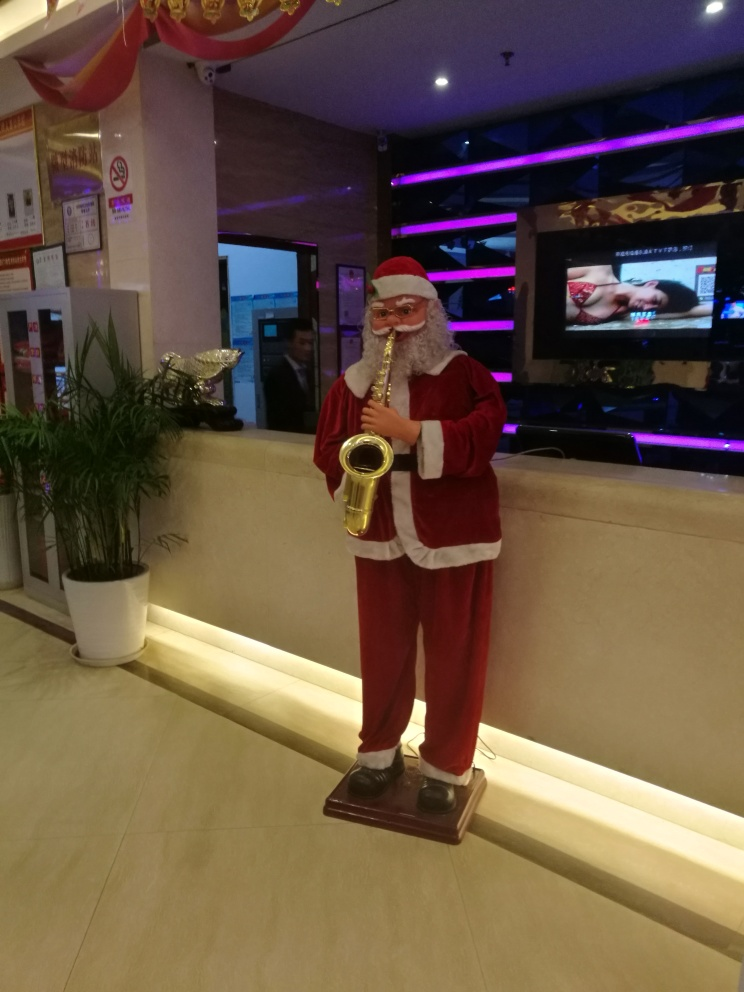Are there any quality issues with this image? Yes, there are several quality issues with the image. The lighting appears to be uneven, with bright spots that could be reflective surfaces or lighting imbalances, impacting the visibility of some areas. Moreover, there is a visible pixelation and blurriness which suggests a low-resolution capture or a high level of digital compression. Additionally, the composition could be improved for better aesthetic appeal as the subject is closely cropped at the bottom. 